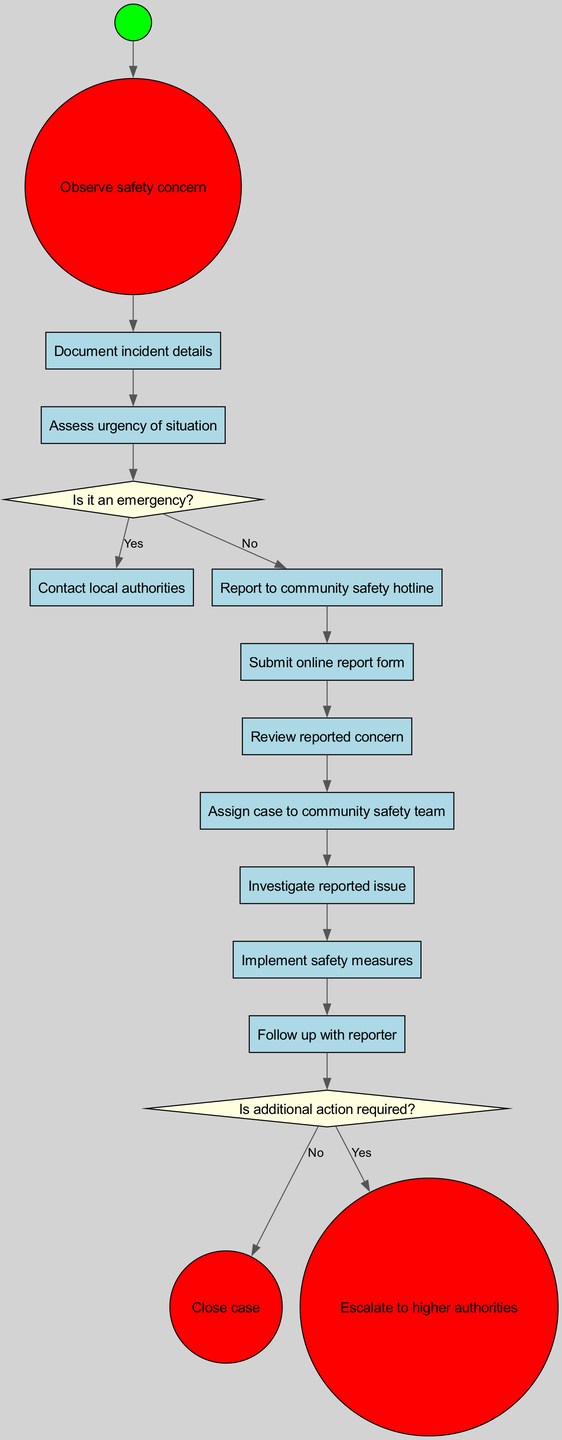What is the initial action in the procedure? The diagram starts with the action "Observe safety concern," which is the first step before further actions are taken.
Answer: Observe safety concern How many activities are listed in the diagram? There are a total of 10 activities outlined that describe the steps in the procedure for reporting safety concerns.
Answer: 10 What is the first decision point in the procedure? The first decision point in the diagram is "Is it an emergency?" This question determines the subsequent actions based on urgency.
Answer: Is it an emergency? What action follows "Report to community safety hotline"? After reporting to the hotline, the next step is to "Submit online report form," indicating a progression in documenting the concern.
Answer: Submit online report form What happens if additional action is required? If additional action is required, the flow leads to "Escalate to higher authorities," indicating a continuation of the process for unresolved safety concerns.
Answer: Escalate to higher authorities How many end nodes are present in the diagram? There are 2 end nodes indicated, which are "Close case" and "Escalate to higher authorities," representing the outcomes of the reporting procedure.
Answer: 2 What is the action taken after "Implement safety measures"? Following the implementation of safety measures, the next action is to "Follow up with reporter," which emphasizes communication with the individual who reported the concern.
Answer: Follow up with reporter What is the action that occurs if it is determined that it is an emergency? If it is determined that it is an emergency, the procedure prompts to "Contact local authorities," indicating immediate and direct action to address the situation.
Answer: Contact local authorities What shape represents the decision nodes in the diagram? The decision nodes are represented by diamond shapes in the diagram, distinguishing them from activity steps which are in rectangular shapes.
Answer: Diamond shapes 